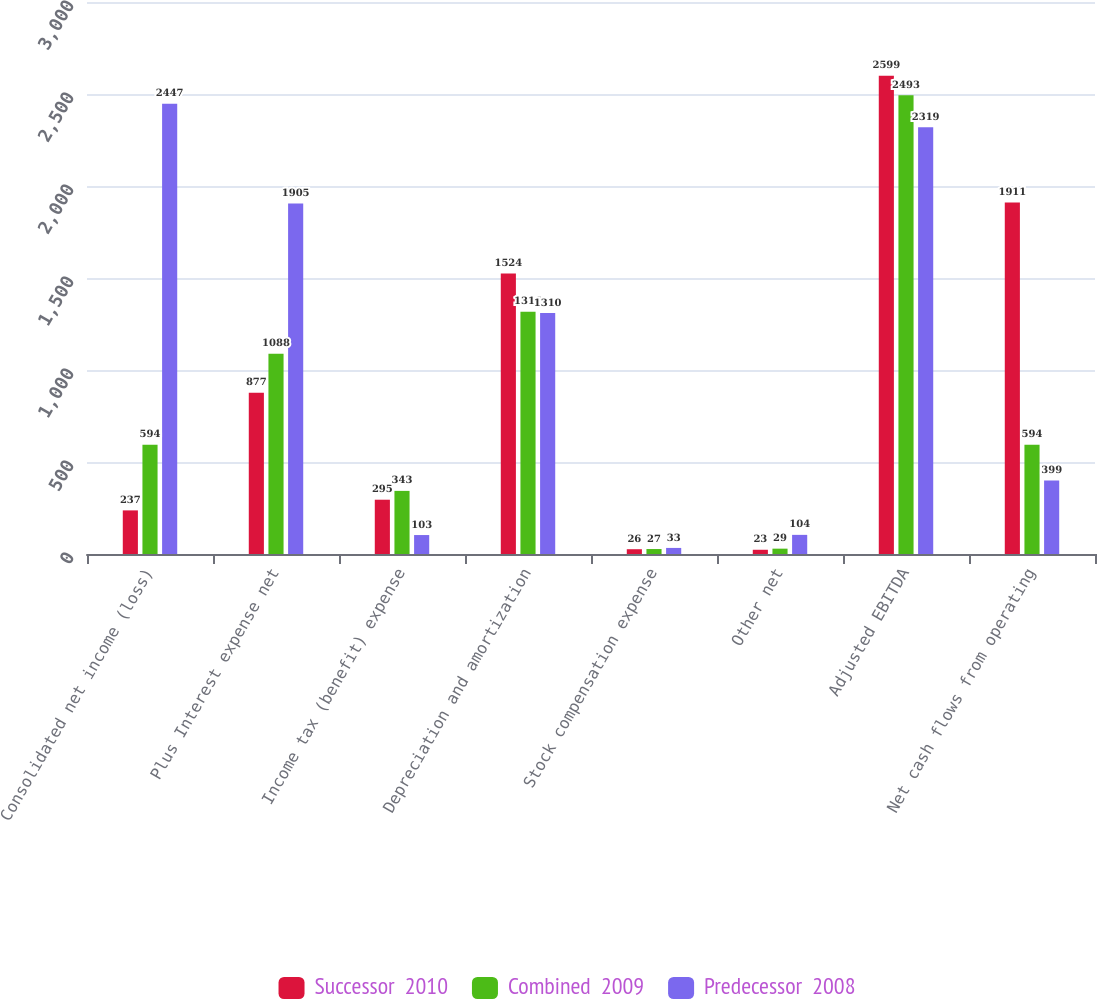<chart> <loc_0><loc_0><loc_500><loc_500><stacked_bar_chart><ecel><fcel>Consolidated net income (loss)<fcel>Plus Interest expense net<fcel>Income tax (benefit) expense<fcel>Depreciation and amortization<fcel>Stock compensation expense<fcel>Other net<fcel>Adjusted EBITDA<fcel>Net cash flows from operating<nl><fcel>Successor  2010<fcel>237<fcel>877<fcel>295<fcel>1524<fcel>26<fcel>23<fcel>2599<fcel>1911<nl><fcel>Combined  2009<fcel>594<fcel>1088<fcel>343<fcel>1316<fcel>27<fcel>29<fcel>2493<fcel>594<nl><fcel>Predecessor  2008<fcel>2447<fcel>1905<fcel>103<fcel>1310<fcel>33<fcel>104<fcel>2319<fcel>399<nl></chart> 